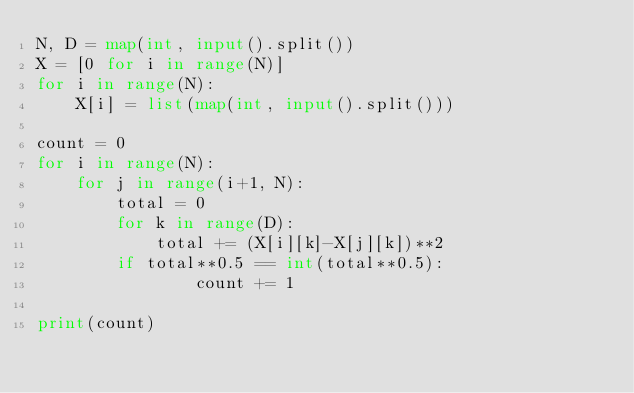Convert code to text. <code><loc_0><loc_0><loc_500><loc_500><_Python_>N, D = map(int, input().split())
X = [0 for i in range(N)]
for i in range(N):
    X[i] = list(map(int, input().split()))

count = 0
for i in range(N):
    for j in range(i+1, N):
        total = 0
        for k in range(D):
            total += (X[i][k]-X[j][k])**2   
        if total**0.5 == int(total**0.5):
                count += 1

print(count)</code> 